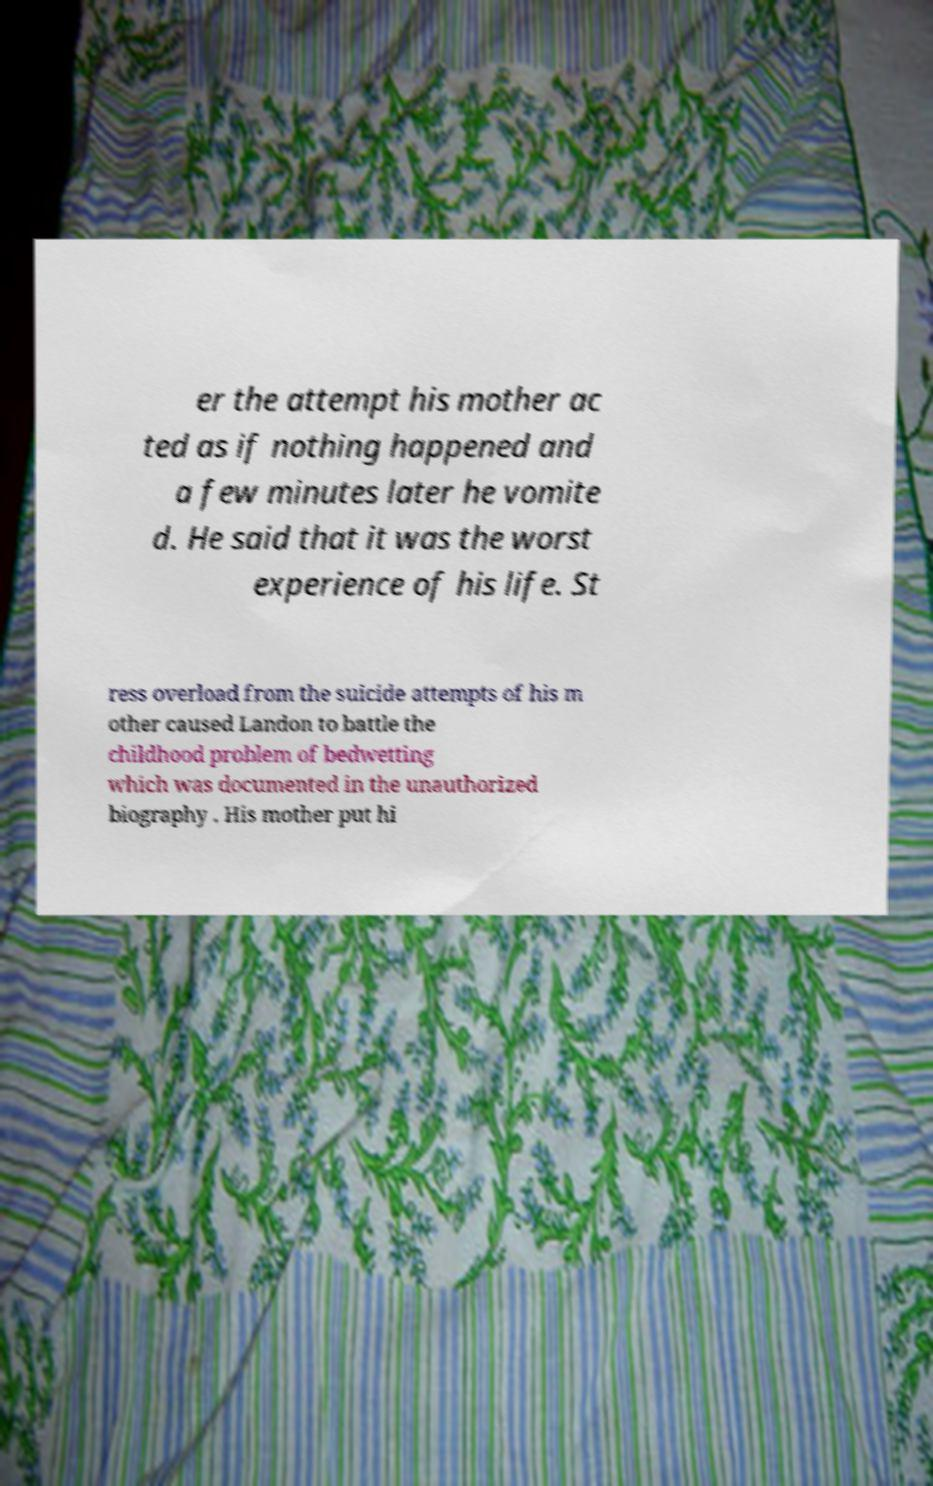Please identify and transcribe the text found in this image. er the attempt his mother ac ted as if nothing happened and a few minutes later he vomite d. He said that it was the worst experience of his life. St ress overload from the suicide attempts of his m other caused Landon to battle the childhood problem of bedwetting which was documented in the unauthorized biography . His mother put hi 